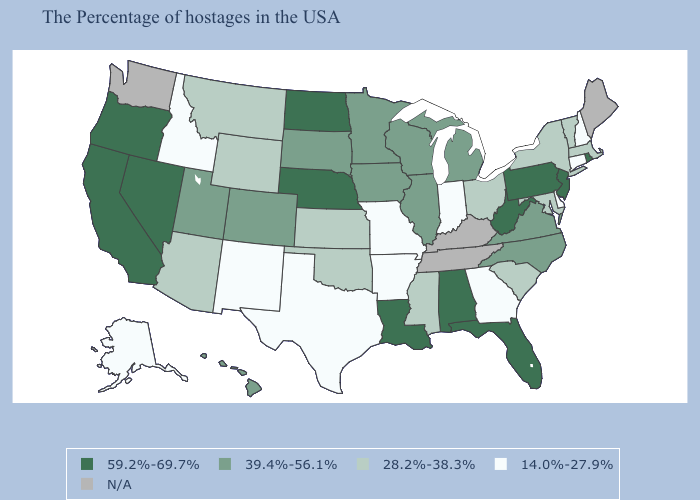Which states have the lowest value in the USA?
Concise answer only. New Hampshire, Connecticut, Delaware, Georgia, Indiana, Missouri, Arkansas, Texas, New Mexico, Idaho, Alaska. Name the states that have a value in the range N/A?
Short answer required. Maine, Kentucky, Tennessee, Washington. Name the states that have a value in the range 39.4%-56.1%?
Be succinct. Virginia, North Carolina, Michigan, Wisconsin, Illinois, Minnesota, Iowa, South Dakota, Colorado, Utah, Hawaii. What is the value of Wisconsin?
Give a very brief answer. 39.4%-56.1%. Name the states that have a value in the range 59.2%-69.7%?
Answer briefly. Rhode Island, New Jersey, Pennsylvania, West Virginia, Florida, Alabama, Louisiana, Nebraska, North Dakota, Nevada, California, Oregon. Which states have the lowest value in the MidWest?
Short answer required. Indiana, Missouri. What is the value of Florida?
Keep it brief. 59.2%-69.7%. Does California have the highest value in the USA?
Concise answer only. Yes. Among the states that border Vermont , does Massachusetts have the lowest value?
Write a very short answer. No. Name the states that have a value in the range 28.2%-38.3%?
Answer briefly. Massachusetts, Vermont, New York, Maryland, South Carolina, Ohio, Mississippi, Kansas, Oklahoma, Wyoming, Montana, Arizona. Among the states that border New Jersey , does Pennsylvania have the highest value?
Quick response, please. Yes. Which states have the lowest value in the USA?
Give a very brief answer. New Hampshire, Connecticut, Delaware, Georgia, Indiana, Missouri, Arkansas, Texas, New Mexico, Idaho, Alaska. What is the value of Oklahoma?
Answer briefly. 28.2%-38.3%. What is the highest value in the Northeast ?
Give a very brief answer. 59.2%-69.7%. What is the value of Rhode Island?
Keep it brief. 59.2%-69.7%. 